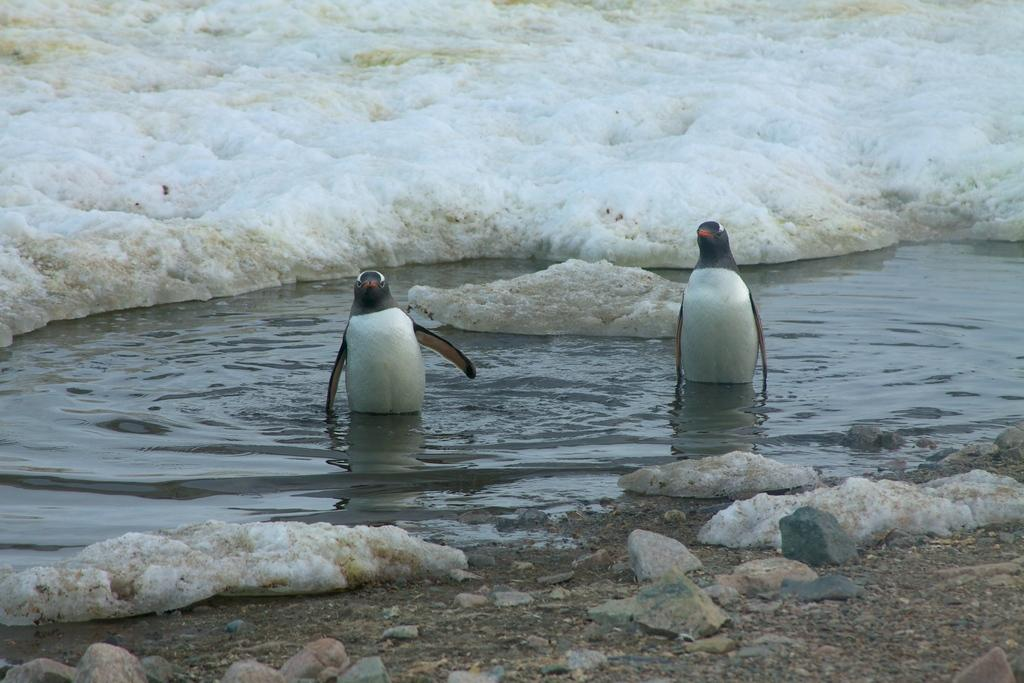What animals are in the water in the image? There are two penguins in the water in the image. What can be seen in the background of the image? There is snow in the background of the image. What is on the ground in the image? There are stones on the ground in the image. What type of cap is the organization wearing in the image? There is no organization or cap present in the image; it features two penguins in the water and snow in the background. 